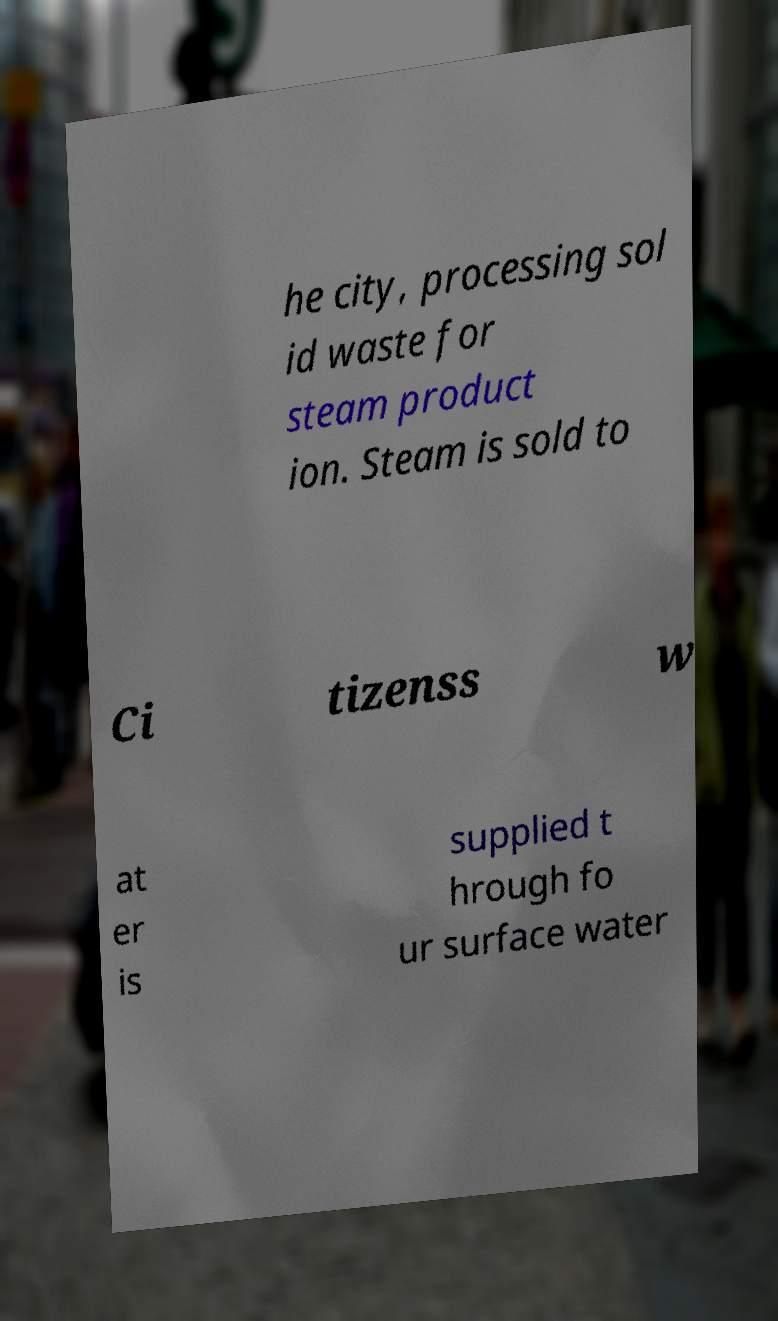I need the written content from this picture converted into text. Can you do that? he city, processing sol id waste for steam product ion. Steam is sold to Ci tizenss w at er is supplied t hrough fo ur surface water 